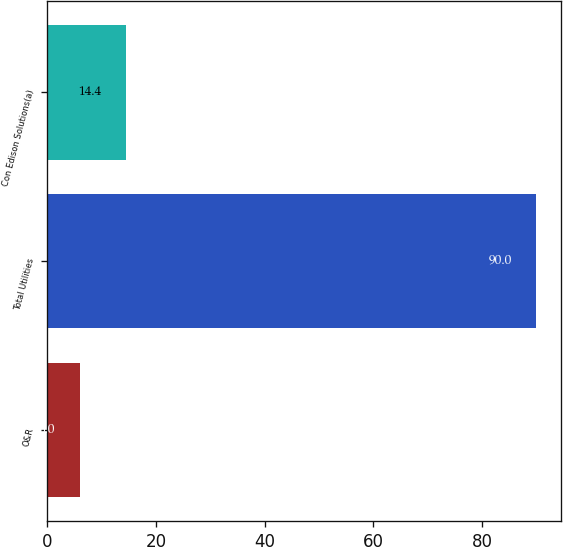Convert chart. <chart><loc_0><loc_0><loc_500><loc_500><bar_chart><fcel>O&R<fcel>Total Utilities<fcel>Con Edison Solutions(a)<nl><fcel>6<fcel>90<fcel>14.4<nl></chart> 